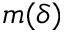<formula> <loc_0><loc_0><loc_500><loc_500>m ( \delta )</formula> 